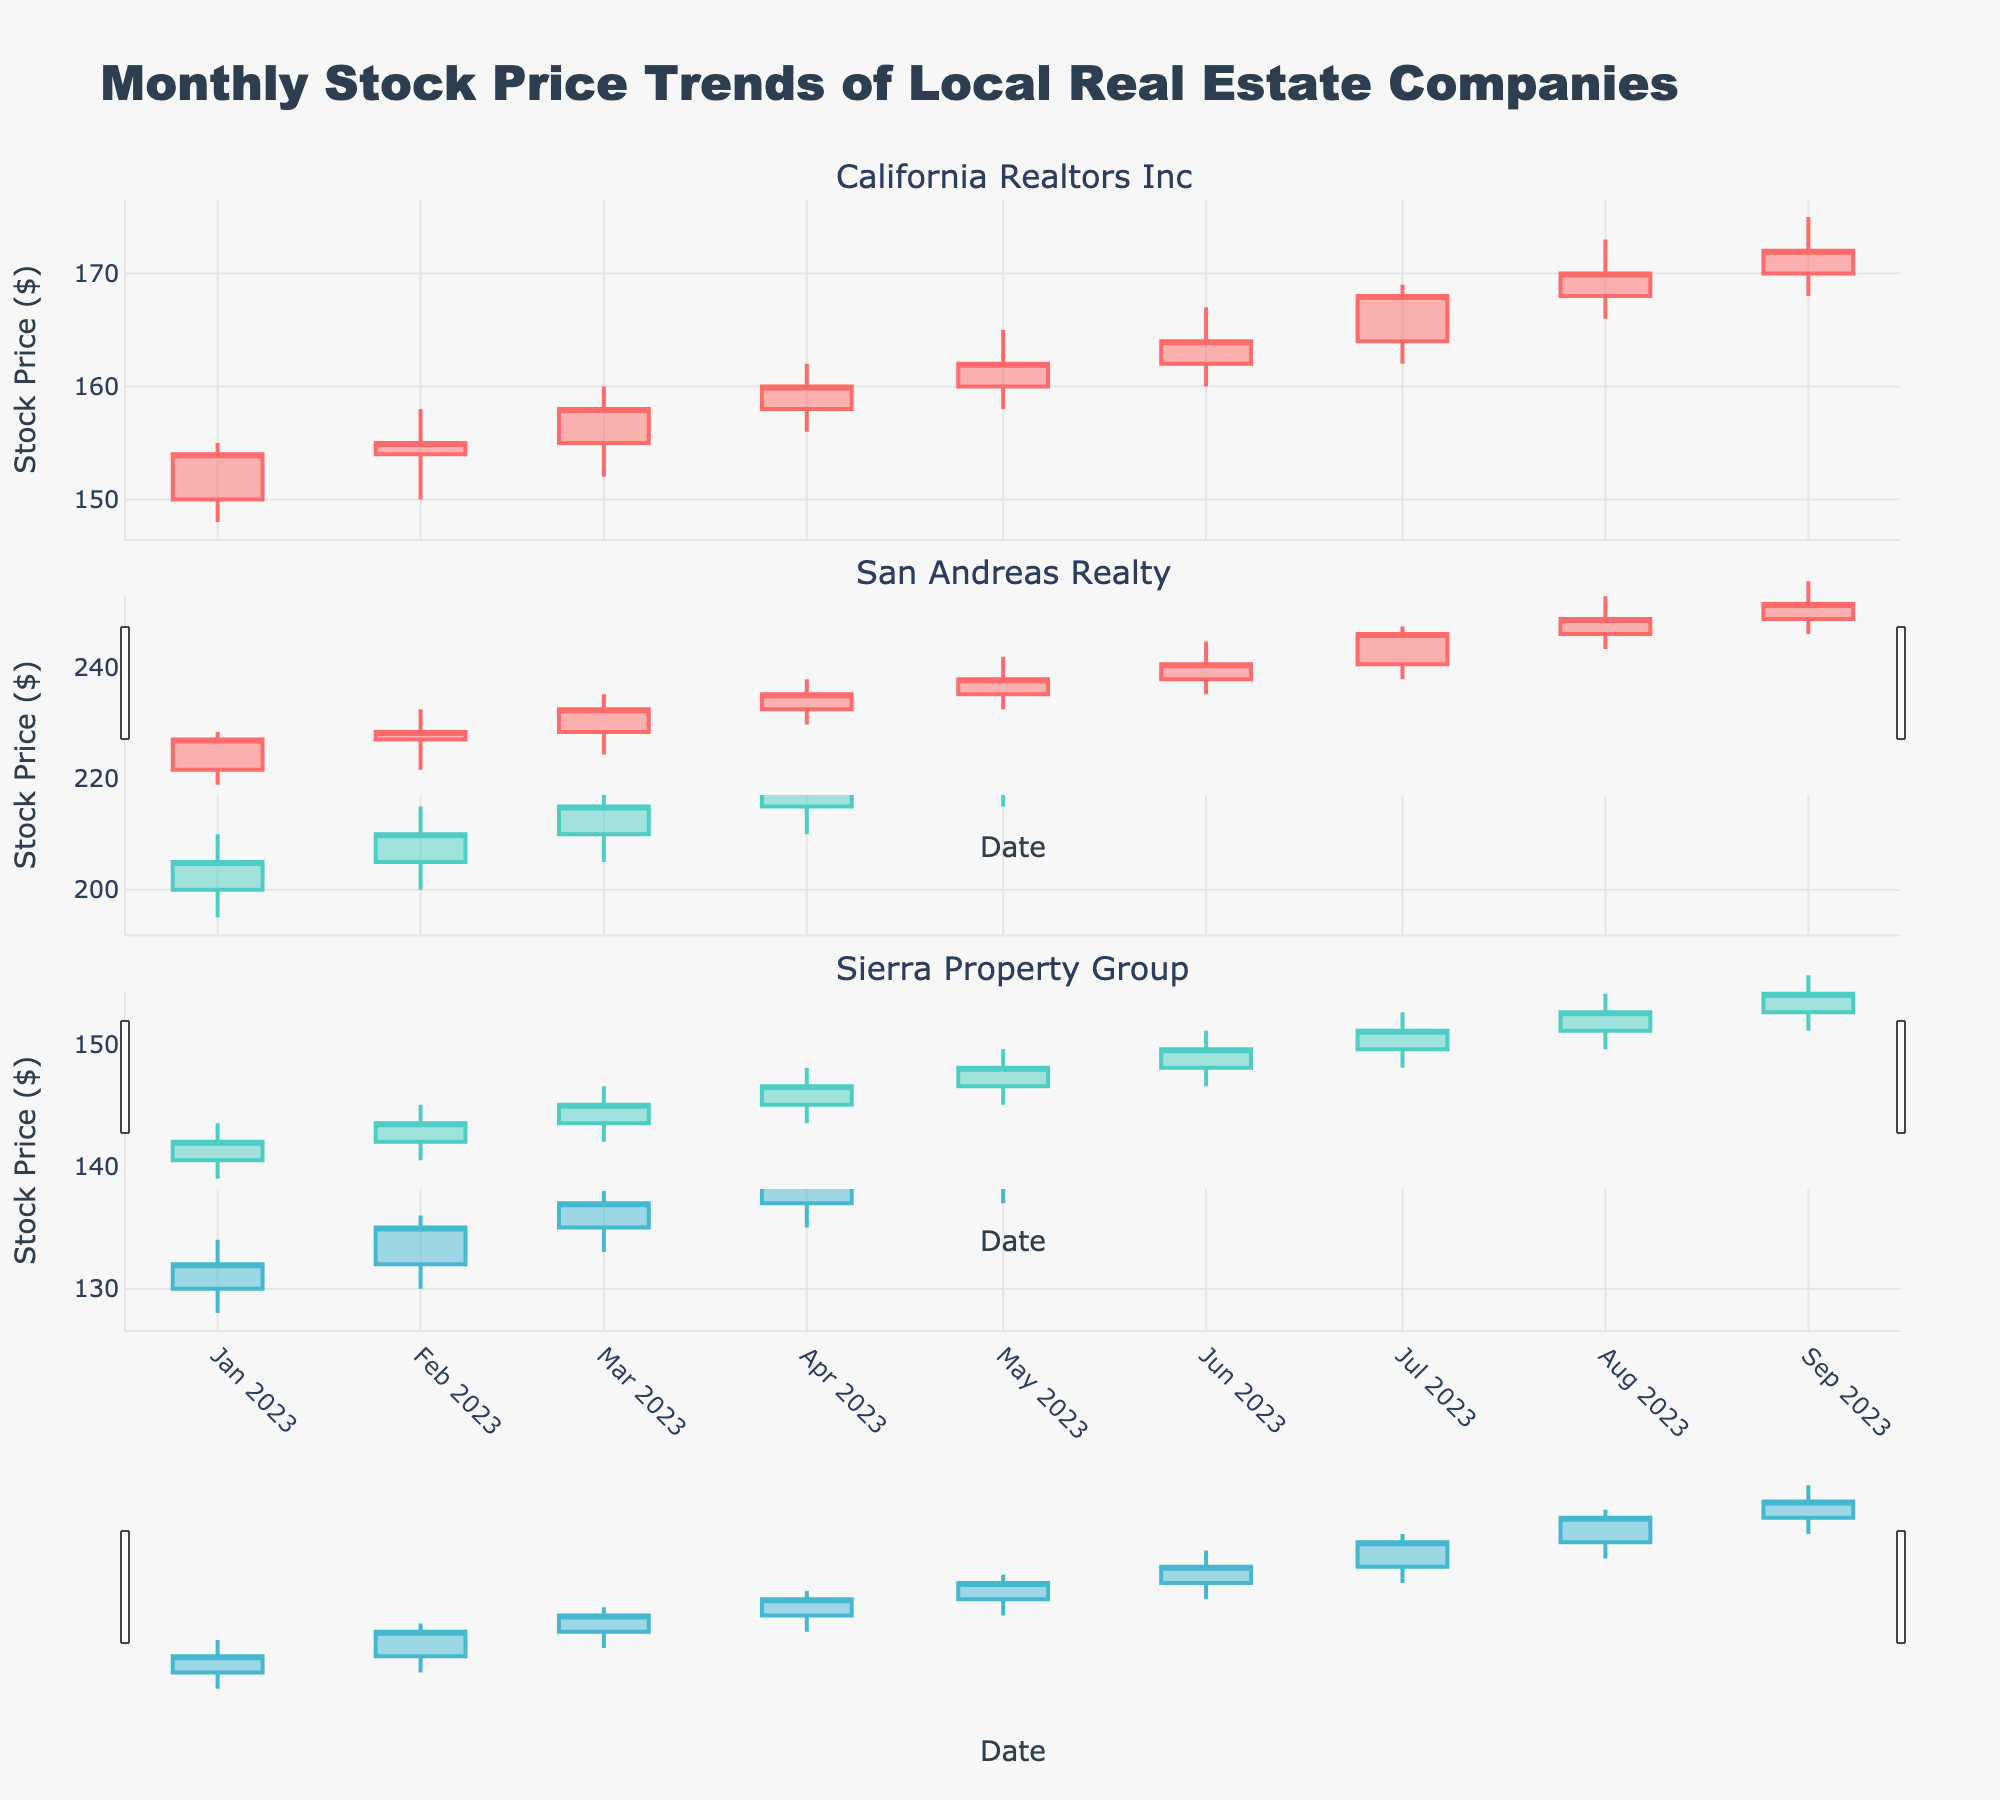What is the title of the figure? The title is clearly mentioned at the top of the figure in a larger, bold font which reads "Monthly Stock Price Trends of Local Real Estate Companies".
Answer: Monthly Stock Price Trends of Local Real Estate Companies What does the x-axis represent in each subplot? Each subplot has the x-axis labeled with "Date" which corresponds to the months for which the data is plotted.
Answer: Date Which company shows the highest closing stock price in September 2023? Observing the candlestick plots, San Andreas Realty has the highest closing stock price at $245 in September 2023.
Answer: San Andreas Realty Which month shows the lowest stock price for Sierra Property Group? By examining the lowest points in the candlesticks for Sierra Property Group, January 2023 has the lowest stock price of $128.
Answer: January 2023 How has the closing stock price of California Realtors Inc changed from January 2023 to September 2023? California Realtors Inc's closing stock price increased from $154 in January 2023 to $172 in September 2023.
Answer: It increased Compare the opening stock prices of San Andreas Realty in July 2023 and August 2023. Which was higher? San Andreas Realty had an opening stock price of $230 in July 2023 and $235 in August 2023. August's opening price was higher.
Answer: August 2023 What is the average closing stock price of Sierra Property Group over the plotted months? The closing prices for Sierra Property Group are: 132, 135, 137, 139, 141, 143, 146, 149, and 151. The average can be calculated as (132+135+137+139+141+143+146+149+151)/9 = 141.67.
Answer: 141.67 Identify the month with the highest volatility for San Andreas Realty and explain how you determined it. Volatility can be seen in the length of the candlesticks, where the difference between the high and low prices is the greatest. For San Andreas Realty, the highest volatility is in September 2023, with a high of $250 and a low of $235, a volatility of $15.
Answer: September 2023 How did the stock price trend for California Realtors Inc change after April 2023? The general trend for California Realtors Inc's stock price shows an upward movement after April 2023, moving from $160 to $172 in September 2023.
Answer: It trended upward 